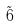Convert formula to latex. <formula><loc_0><loc_0><loc_500><loc_500>\tilde { 6 }</formula> 